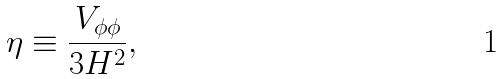<formula> <loc_0><loc_0><loc_500><loc_500>\eta \equiv \frac { V _ { \phi \phi } } { 3 H ^ { 2 } } ,</formula> 